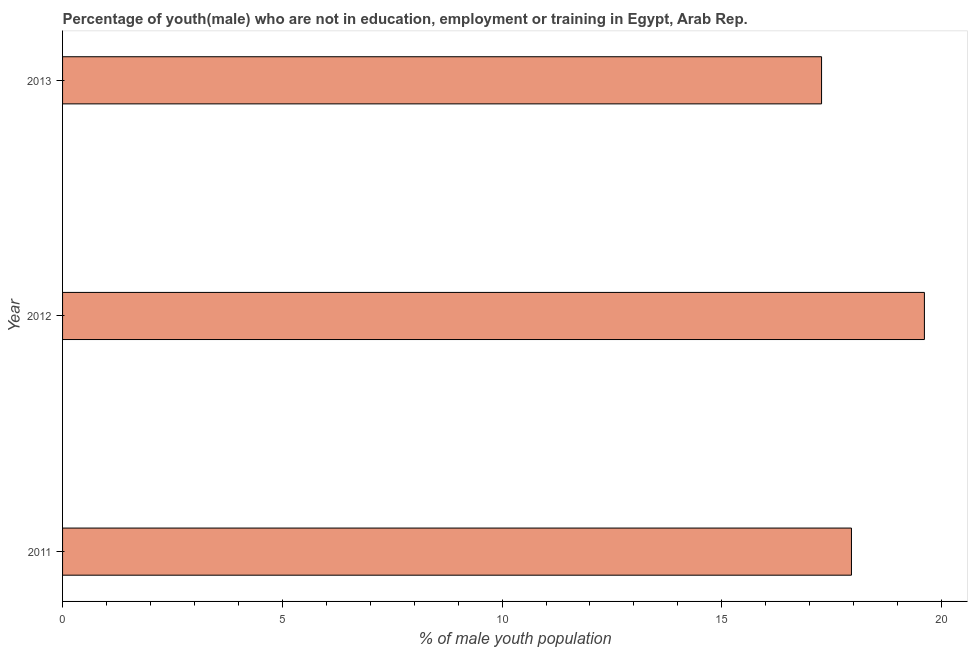Does the graph contain any zero values?
Your answer should be very brief. No. Does the graph contain grids?
Keep it short and to the point. No. What is the title of the graph?
Your response must be concise. Percentage of youth(male) who are not in education, employment or training in Egypt, Arab Rep. What is the label or title of the X-axis?
Your answer should be compact. % of male youth population. What is the unemployed male youth population in 2011?
Ensure brevity in your answer.  17.95. Across all years, what is the maximum unemployed male youth population?
Make the answer very short. 19.61. Across all years, what is the minimum unemployed male youth population?
Provide a short and direct response. 17.27. In which year was the unemployed male youth population maximum?
Provide a succinct answer. 2012. What is the sum of the unemployed male youth population?
Provide a succinct answer. 54.83. What is the difference between the unemployed male youth population in 2011 and 2013?
Your answer should be very brief. 0.68. What is the average unemployed male youth population per year?
Give a very brief answer. 18.28. What is the median unemployed male youth population?
Ensure brevity in your answer.  17.95. What is the ratio of the unemployed male youth population in 2012 to that in 2013?
Your response must be concise. 1.14. Is the unemployed male youth population in 2011 less than that in 2012?
Offer a terse response. Yes. Is the difference between the unemployed male youth population in 2012 and 2013 greater than the difference between any two years?
Your answer should be compact. Yes. What is the difference between the highest and the second highest unemployed male youth population?
Offer a terse response. 1.66. Is the sum of the unemployed male youth population in 2012 and 2013 greater than the maximum unemployed male youth population across all years?
Ensure brevity in your answer.  Yes. What is the difference between the highest and the lowest unemployed male youth population?
Make the answer very short. 2.34. In how many years, is the unemployed male youth population greater than the average unemployed male youth population taken over all years?
Your answer should be very brief. 1. How many bars are there?
Your answer should be very brief. 3. How many years are there in the graph?
Your answer should be very brief. 3. What is the difference between two consecutive major ticks on the X-axis?
Make the answer very short. 5. What is the % of male youth population in 2011?
Your response must be concise. 17.95. What is the % of male youth population of 2012?
Your response must be concise. 19.61. What is the % of male youth population of 2013?
Give a very brief answer. 17.27. What is the difference between the % of male youth population in 2011 and 2012?
Provide a succinct answer. -1.66. What is the difference between the % of male youth population in 2011 and 2013?
Your answer should be compact. 0.68. What is the difference between the % of male youth population in 2012 and 2013?
Make the answer very short. 2.34. What is the ratio of the % of male youth population in 2011 to that in 2012?
Your answer should be compact. 0.92. What is the ratio of the % of male youth population in 2011 to that in 2013?
Provide a short and direct response. 1.04. What is the ratio of the % of male youth population in 2012 to that in 2013?
Make the answer very short. 1.14. 